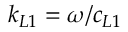<formula> <loc_0><loc_0><loc_500><loc_500>k _ { L 1 } = \omega / c _ { L 1 }</formula> 